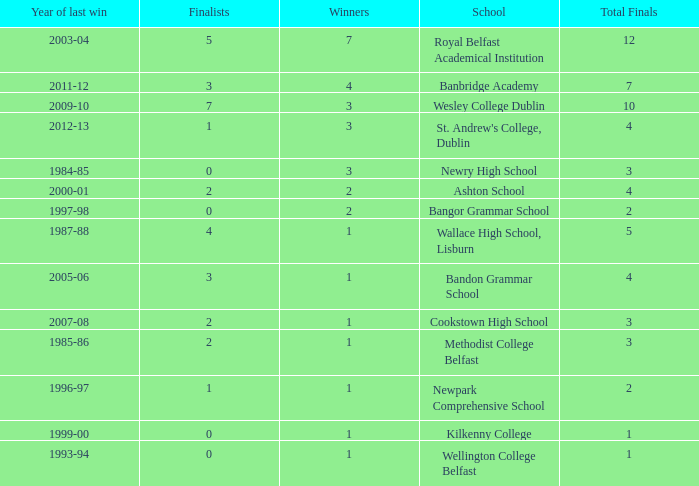What are the names that had a finalist score of 2? Ashton School, Cookstown High School, Methodist College Belfast. 